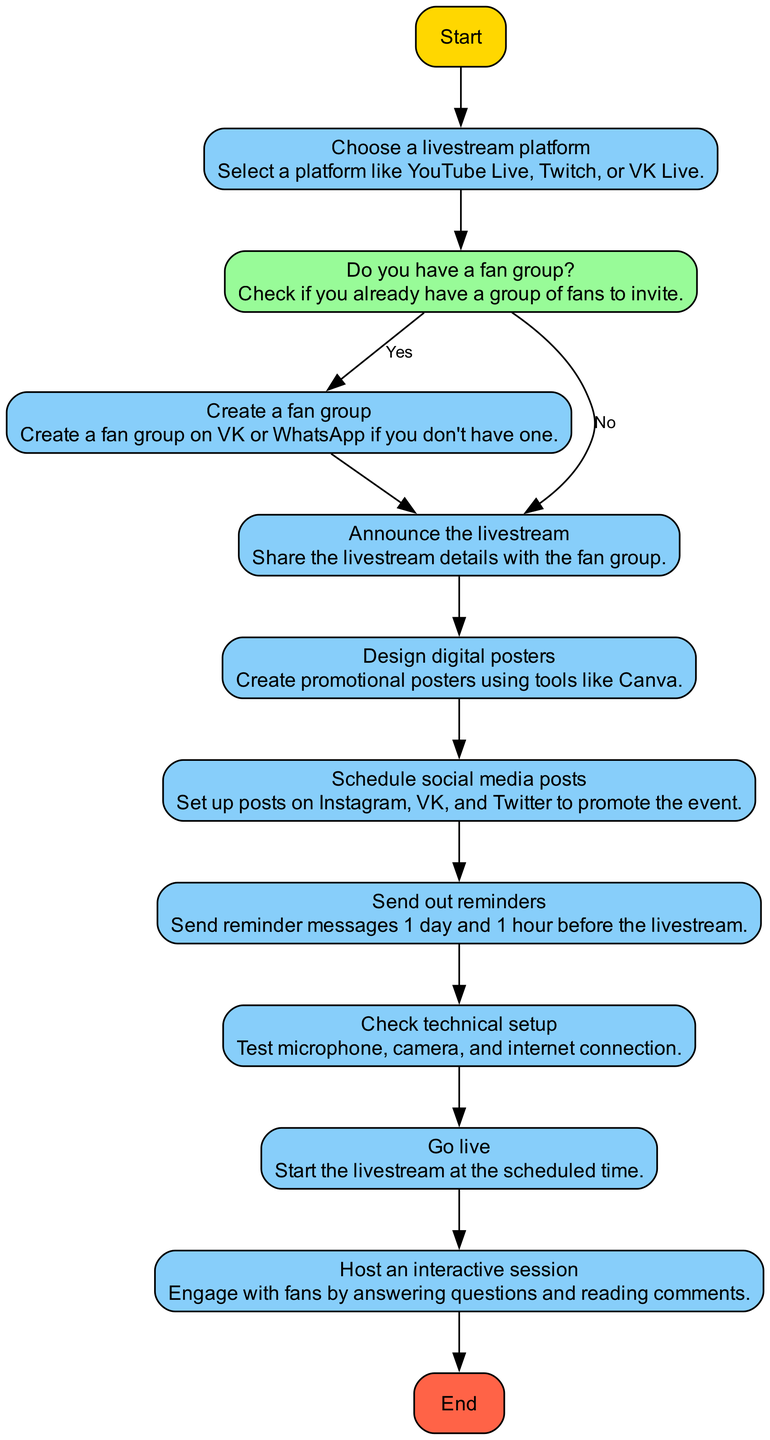What is the first step in the diagram? The first step in the flowchart is labeled "Start," indicating the beginning of the process.
Answer: Start How many action nodes are there in the flowchart? By counting the nodes, there are seven action nodes in total, from choosing a platform to hosting an interactive session.
Answer: Seven What platform options can be chosen for the livestream? The flowchart suggests platforms like YouTube Live, Twitch, or VK Live for the livestream.
Answer: YouTube Live, Twitch, VK Live What should be done if there is no fan group? The flowchart indicates that if there is no fan group, one should create a fan group on VK or WhatsApp.
Answer: Create a fan group How many reminders should be sent out? The flowchart mentions sending out reminders one day and one hour before the livestream, which totals two reminders.
Answer: Two reminders What happens after announcing the livestream? After announcing the livestream, the next step is to design digital posters to promote the event.
Answer: Design digital posters What must be checked before going live? The flowchart specifies that it is important to check the technical setup, including the microphone, camera, and internet connection, before going live.
Answer: Check technical setup What is the last step in the flowchart? The last step in the flowchart is labeled "End," indicating the conclusion of the process after hosting the interactive session.
Answer: End 